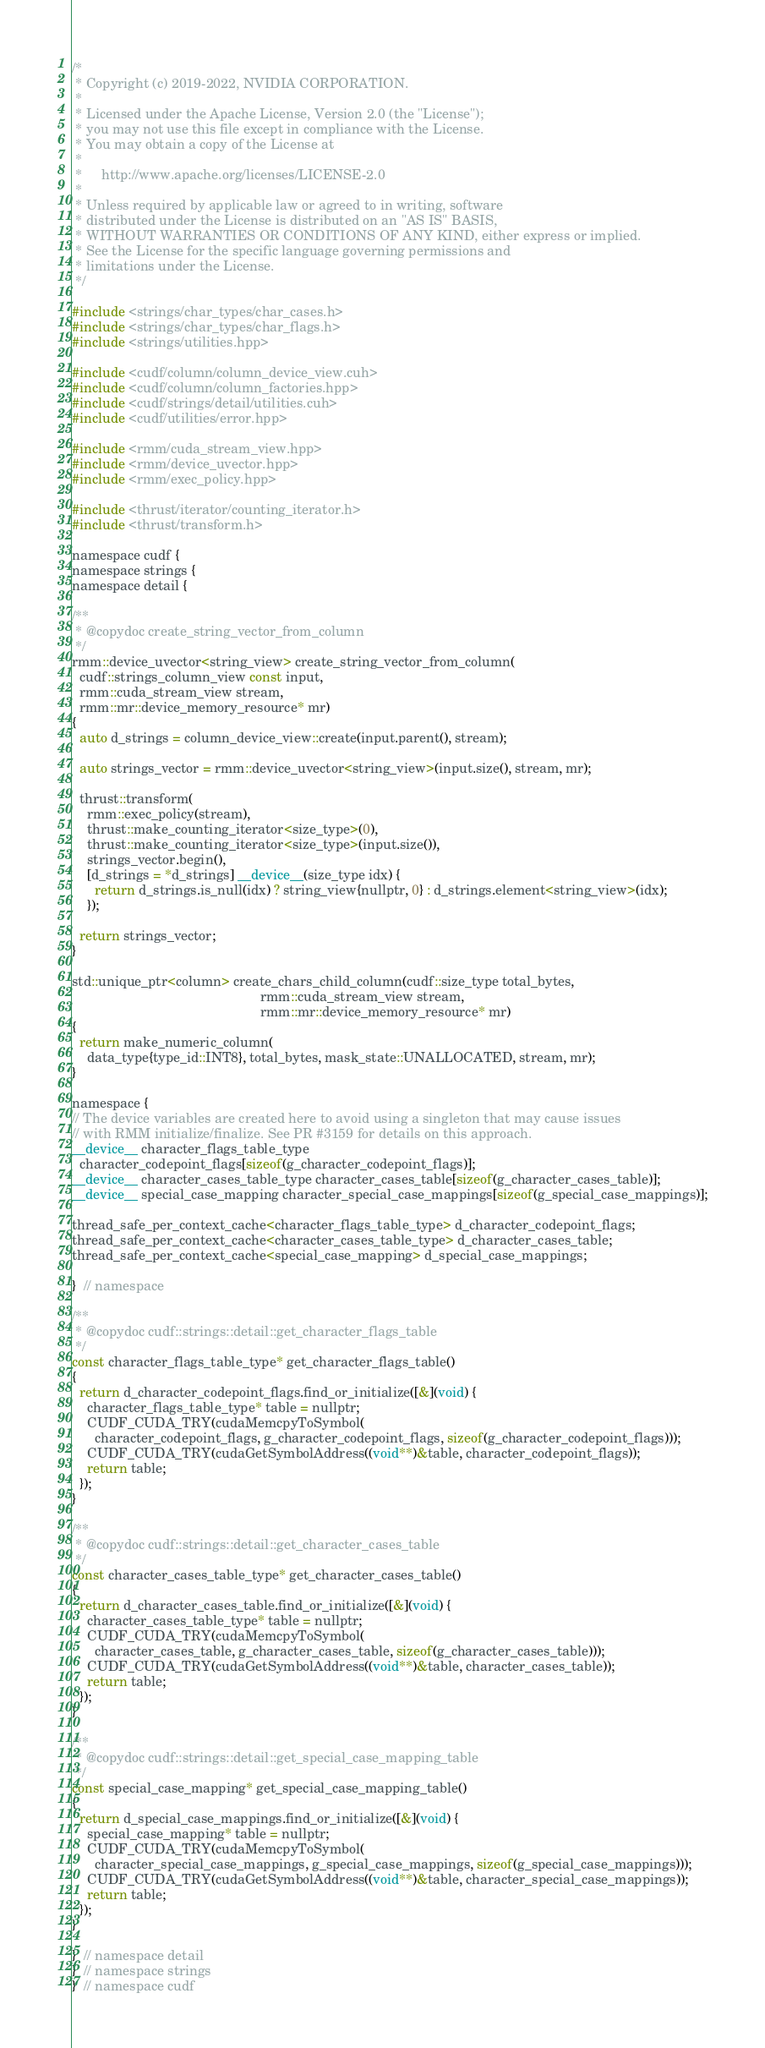<code> <loc_0><loc_0><loc_500><loc_500><_Cuda_>/*
 * Copyright (c) 2019-2022, NVIDIA CORPORATION.
 *
 * Licensed under the Apache License, Version 2.0 (the "License");
 * you may not use this file except in compliance with the License.
 * You may obtain a copy of the License at
 *
 *     http://www.apache.org/licenses/LICENSE-2.0
 *
 * Unless required by applicable law or agreed to in writing, software
 * distributed under the License is distributed on an "AS IS" BASIS,
 * WITHOUT WARRANTIES OR CONDITIONS OF ANY KIND, either express or implied.
 * See the License for the specific language governing permissions and
 * limitations under the License.
 */

#include <strings/char_types/char_cases.h>
#include <strings/char_types/char_flags.h>
#include <strings/utilities.hpp>

#include <cudf/column/column_device_view.cuh>
#include <cudf/column/column_factories.hpp>
#include <cudf/strings/detail/utilities.cuh>
#include <cudf/utilities/error.hpp>

#include <rmm/cuda_stream_view.hpp>
#include <rmm/device_uvector.hpp>
#include <rmm/exec_policy.hpp>

#include <thrust/iterator/counting_iterator.h>
#include <thrust/transform.h>

namespace cudf {
namespace strings {
namespace detail {

/**
 * @copydoc create_string_vector_from_column
 */
rmm::device_uvector<string_view> create_string_vector_from_column(
  cudf::strings_column_view const input,
  rmm::cuda_stream_view stream,
  rmm::mr::device_memory_resource* mr)
{
  auto d_strings = column_device_view::create(input.parent(), stream);

  auto strings_vector = rmm::device_uvector<string_view>(input.size(), stream, mr);

  thrust::transform(
    rmm::exec_policy(stream),
    thrust::make_counting_iterator<size_type>(0),
    thrust::make_counting_iterator<size_type>(input.size()),
    strings_vector.begin(),
    [d_strings = *d_strings] __device__(size_type idx) {
      return d_strings.is_null(idx) ? string_view{nullptr, 0} : d_strings.element<string_view>(idx);
    });

  return strings_vector;
}

std::unique_ptr<column> create_chars_child_column(cudf::size_type total_bytes,
                                                  rmm::cuda_stream_view stream,
                                                  rmm::mr::device_memory_resource* mr)
{
  return make_numeric_column(
    data_type{type_id::INT8}, total_bytes, mask_state::UNALLOCATED, stream, mr);
}

namespace {
// The device variables are created here to avoid using a singleton that may cause issues
// with RMM initialize/finalize. See PR #3159 for details on this approach.
__device__ character_flags_table_type
  character_codepoint_flags[sizeof(g_character_codepoint_flags)];
__device__ character_cases_table_type character_cases_table[sizeof(g_character_cases_table)];
__device__ special_case_mapping character_special_case_mappings[sizeof(g_special_case_mappings)];

thread_safe_per_context_cache<character_flags_table_type> d_character_codepoint_flags;
thread_safe_per_context_cache<character_cases_table_type> d_character_cases_table;
thread_safe_per_context_cache<special_case_mapping> d_special_case_mappings;

}  // namespace

/**
 * @copydoc cudf::strings::detail::get_character_flags_table
 */
const character_flags_table_type* get_character_flags_table()
{
  return d_character_codepoint_flags.find_or_initialize([&](void) {
    character_flags_table_type* table = nullptr;
    CUDF_CUDA_TRY(cudaMemcpyToSymbol(
      character_codepoint_flags, g_character_codepoint_flags, sizeof(g_character_codepoint_flags)));
    CUDF_CUDA_TRY(cudaGetSymbolAddress((void**)&table, character_codepoint_flags));
    return table;
  });
}

/**
 * @copydoc cudf::strings::detail::get_character_cases_table
 */
const character_cases_table_type* get_character_cases_table()
{
  return d_character_cases_table.find_or_initialize([&](void) {
    character_cases_table_type* table = nullptr;
    CUDF_CUDA_TRY(cudaMemcpyToSymbol(
      character_cases_table, g_character_cases_table, sizeof(g_character_cases_table)));
    CUDF_CUDA_TRY(cudaGetSymbolAddress((void**)&table, character_cases_table));
    return table;
  });
}

/**
 * @copydoc cudf::strings::detail::get_special_case_mapping_table
 */
const special_case_mapping* get_special_case_mapping_table()
{
  return d_special_case_mappings.find_or_initialize([&](void) {
    special_case_mapping* table = nullptr;
    CUDF_CUDA_TRY(cudaMemcpyToSymbol(
      character_special_case_mappings, g_special_case_mappings, sizeof(g_special_case_mappings)));
    CUDF_CUDA_TRY(cudaGetSymbolAddress((void**)&table, character_special_case_mappings));
    return table;
  });
}

}  // namespace detail
}  // namespace strings
}  // namespace cudf
</code> 